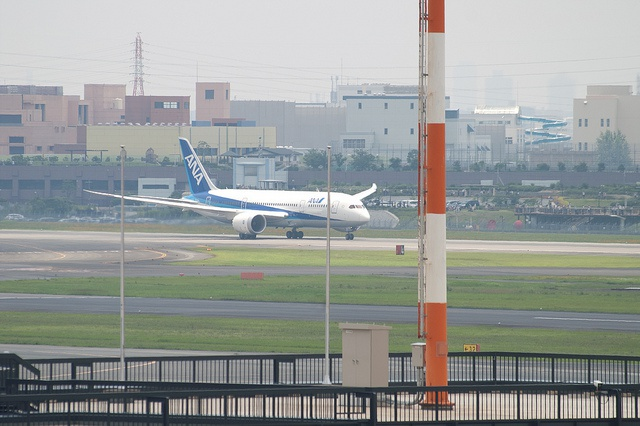Describe the objects in this image and their specific colors. I can see airplane in lightgray, white, darkgray, and gray tones, car in lightgray, darkgray, and gray tones, car in lightgray, darkgray, gray, and lightblue tones, people in lightgray and gray tones, and people in lightgray, darkgray, and gray tones in this image. 